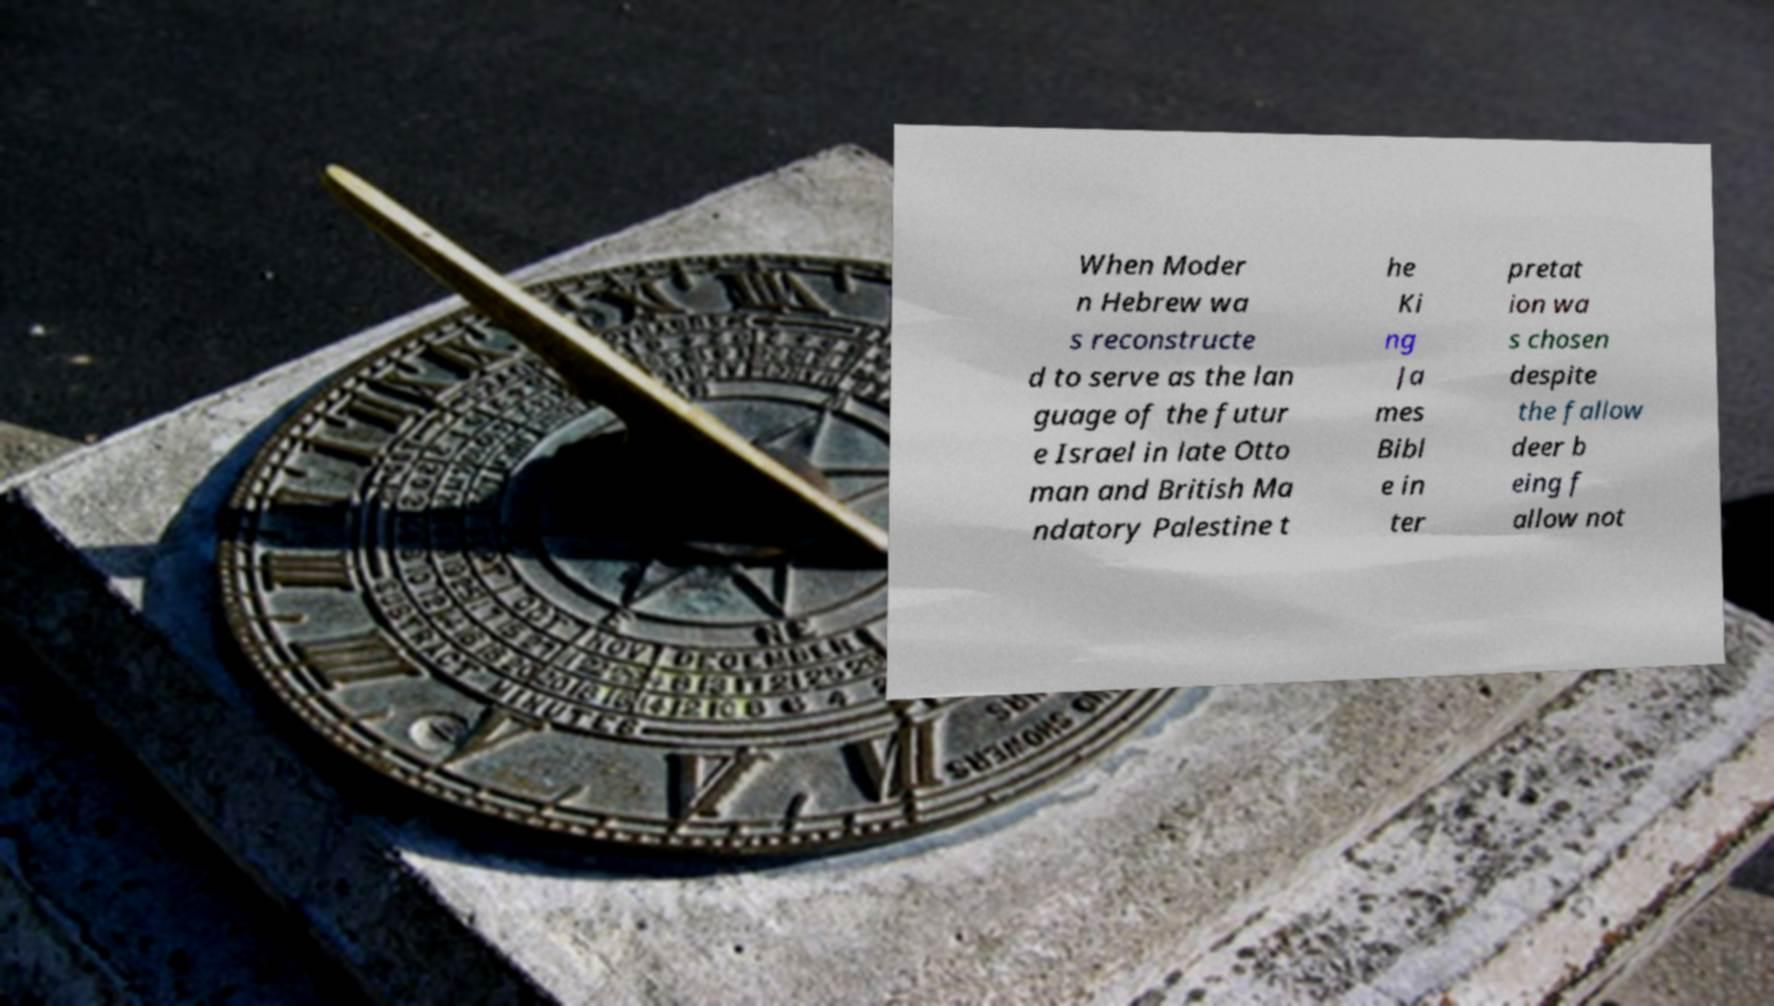For documentation purposes, I need the text within this image transcribed. Could you provide that? When Moder n Hebrew wa s reconstructe d to serve as the lan guage of the futur e Israel in late Otto man and British Ma ndatory Palestine t he Ki ng Ja mes Bibl e in ter pretat ion wa s chosen despite the fallow deer b eing f allow not 